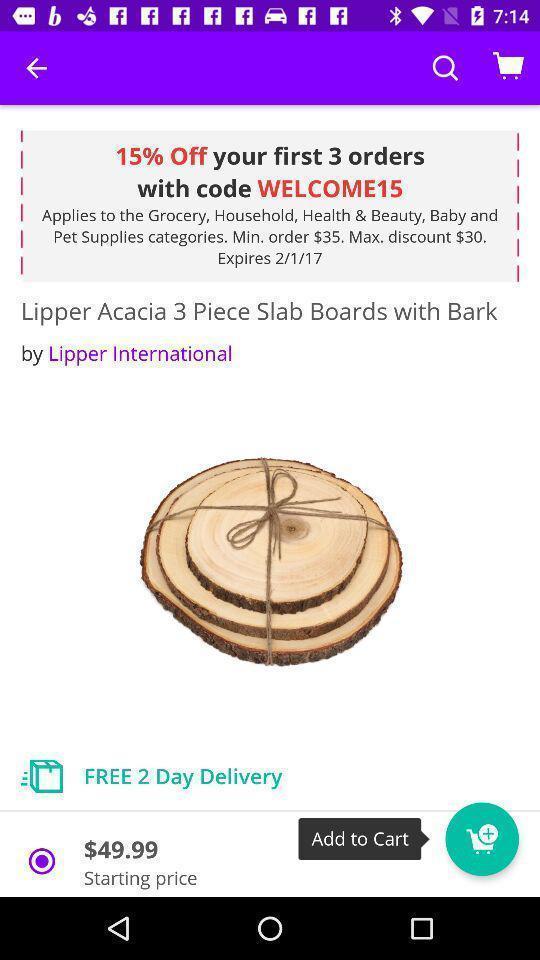Give me a narrative description of this picture. Page showing a product on a shopping app. 